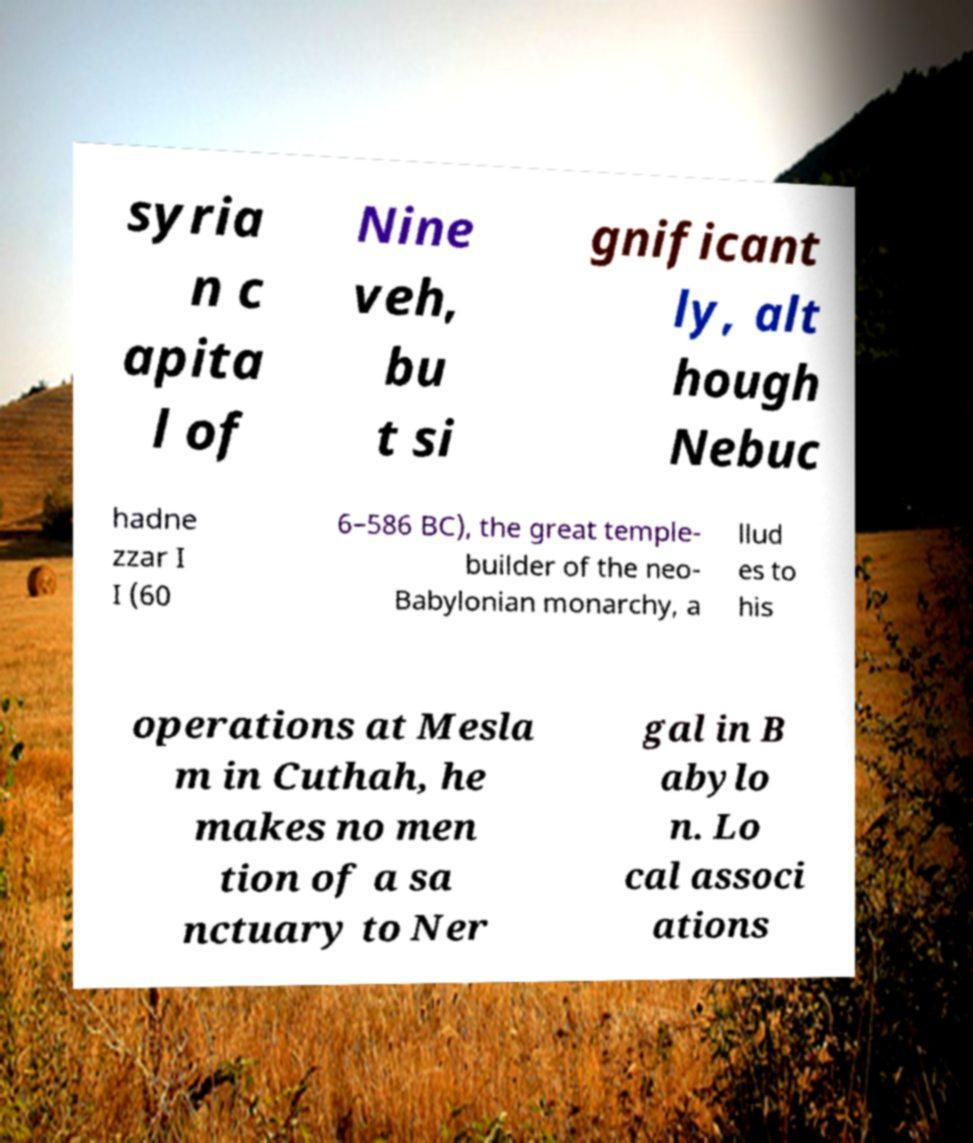Please read and relay the text visible in this image. What does it say? syria n c apita l of Nine veh, bu t si gnificant ly, alt hough Nebuc hadne zzar I I (60 6–586 BC), the great temple- builder of the neo- Babylonian monarchy, a llud es to his operations at Mesla m in Cuthah, he makes no men tion of a sa nctuary to Ner gal in B abylo n. Lo cal associ ations 